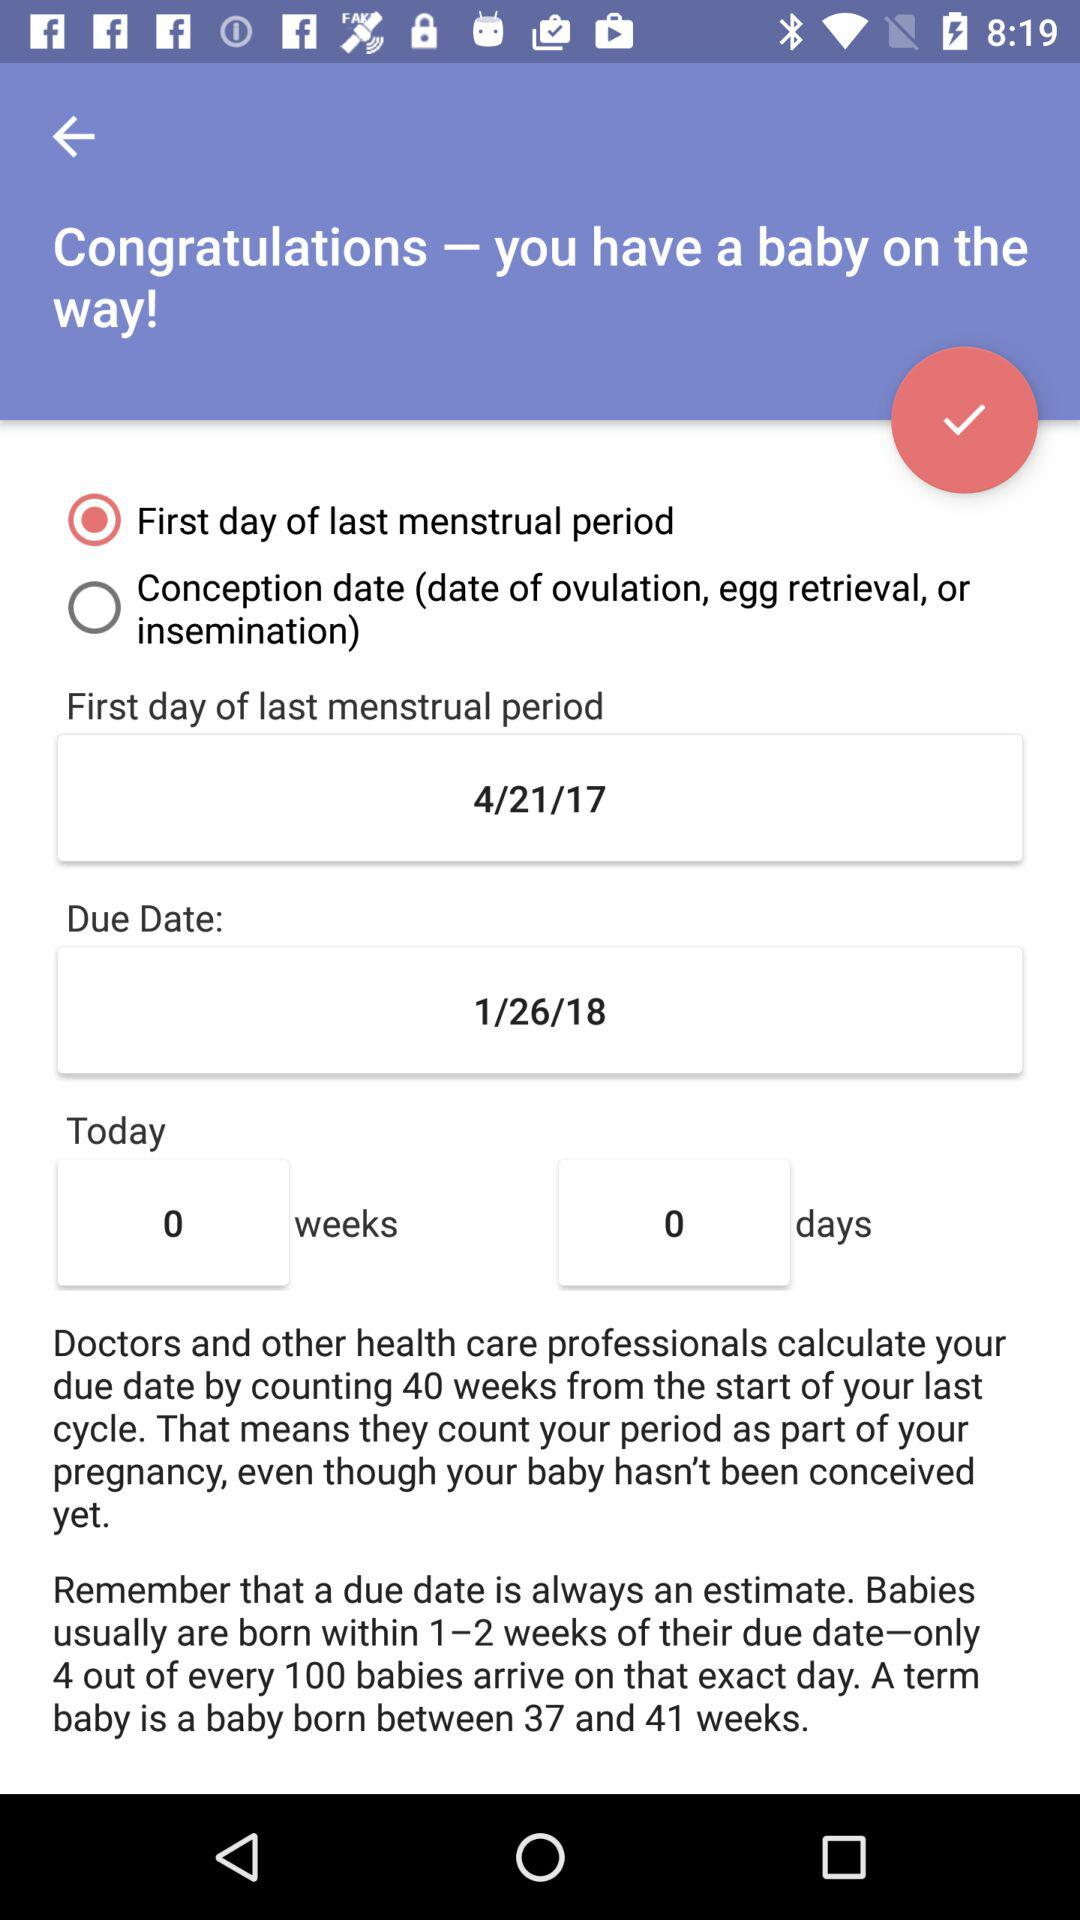What is the status of the "first day of last menstrual period"? The status of the "first day of last menstrual period" is on. 